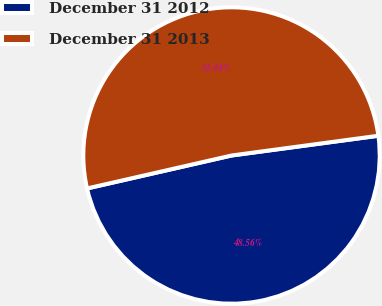Convert chart. <chart><loc_0><loc_0><loc_500><loc_500><pie_chart><fcel>December 31 2012<fcel>December 31 2013<nl><fcel>48.56%<fcel>51.44%<nl></chart> 